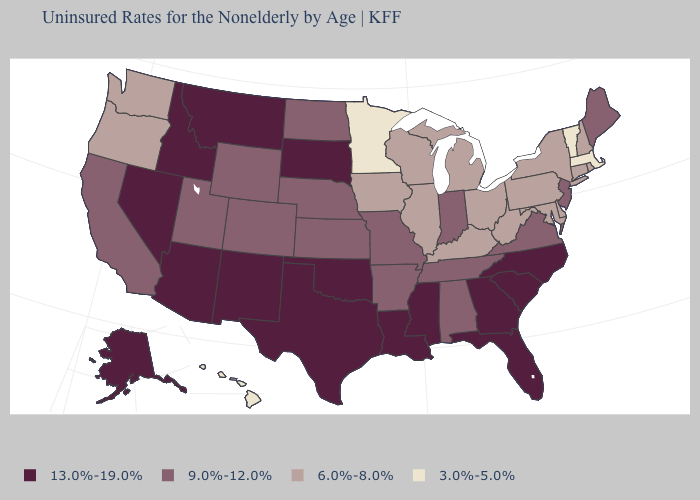What is the value of Maryland?
Short answer required. 6.0%-8.0%. Which states have the lowest value in the West?
Quick response, please. Hawaii. What is the value of Alaska?
Give a very brief answer. 13.0%-19.0%. Does Vermont have the same value as Massachusetts?
Short answer required. Yes. Name the states that have a value in the range 13.0%-19.0%?
Concise answer only. Alaska, Arizona, Florida, Georgia, Idaho, Louisiana, Mississippi, Montana, Nevada, New Mexico, North Carolina, Oklahoma, South Carolina, South Dakota, Texas. Does New Jersey have the lowest value in the USA?
Give a very brief answer. No. What is the value of South Carolina?
Keep it brief. 13.0%-19.0%. Does Tennessee have the highest value in the South?
Write a very short answer. No. Is the legend a continuous bar?
Write a very short answer. No. What is the value of Minnesota?
Answer briefly. 3.0%-5.0%. Does Delaware have the lowest value in the South?
Short answer required. Yes. What is the value of Maine?
Short answer required. 9.0%-12.0%. What is the value of North Dakota?
Short answer required. 9.0%-12.0%. Name the states that have a value in the range 6.0%-8.0%?
Short answer required. Connecticut, Delaware, Illinois, Iowa, Kentucky, Maryland, Michigan, New Hampshire, New York, Ohio, Oregon, Pennsylvania, Rhode Island, Washington, West Virginia, Wisconsin. Does Kentucky have a lower value than Minnesota?
Answer briefly. No. 